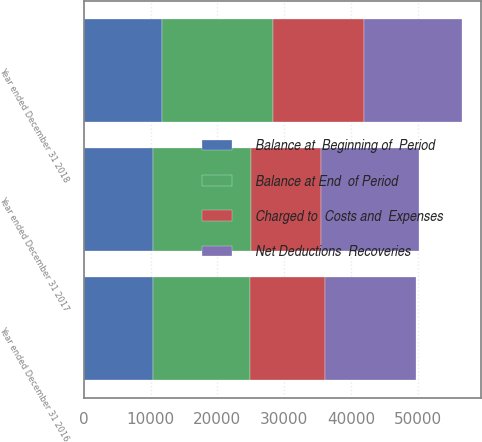<chart> <loc_0><loc_0><loc_500><loc_500><stacked_bar_chart><ecel><fcel>Year ended December 31 2018<fcel>Year ended December 31 2017<fcel>Year ended December 31 2016<nl><fcel>Net Deductions  Recoveries<fcel>14706<fcel>14600<fcel>13636<nl><fcel>Charged to  Costs and  Expenses<fcel>13606<fcel>10455<fcel>11257<nl><fcel>Balance at  Beginning of  Period<fcel>11646<fcel>10349<fcel>10293<nl><fcel>Balance at End  of Period<fcel>16666<fcel>14706<fcel>14600<nl></chart> 